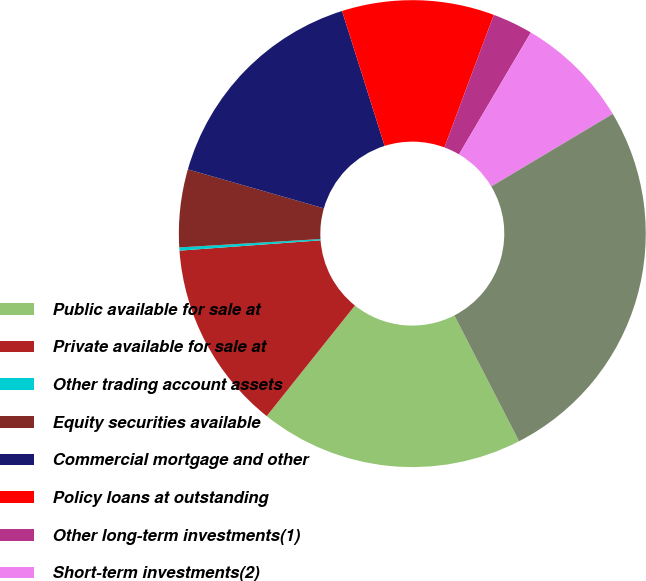Convert chart to OTSL. <chart><loc_0><loc_0><loc_500><loc_500><pie_chart><fcel>Public available for sale at<fcel>Private available for sale at<fcel>Other trading account assets<fcel>Equity securities available<fcel>Commercial mortgage and other<fcel>Policy loans at outstanding<fcel>Other long-term investments(1)<fcel>Short-term investments(2)<fcel>Total general account<nl><fcel>18.28%<fcel>13.12%<fcel>0.22%<fcel>5.38%<fcel>15.7%<fcel>10.54%<fcel>2.8%<fcel>7.96%<fcel>26.01%<nl></chart> 